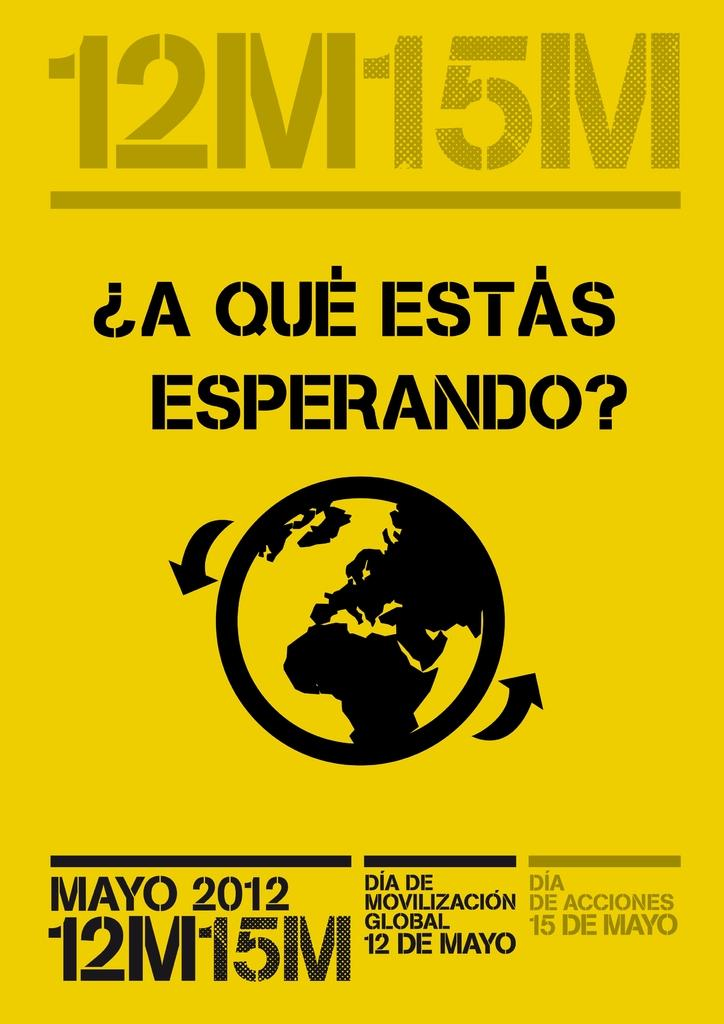<image>
Give a short and clear explanation of the subsequent image. A poster is promoting a global mobilization day on May 12th, 2012. 